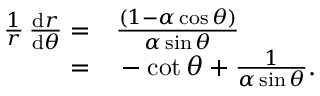Convert formula to latex. <formula><loc_0><loc_0><loc_500><loc_500>\begin{array} { r l } { \frac { 1 } { r } \, \frac { d r } { d \theta } = } & \frac { ( 1 - \alpha \cos \theta ) } { \alpha \sin \theta } } \\ { = } & - \cot \theta + \frac { 1 } { \alpha \sin \theta } . } \end{array}</formula> 